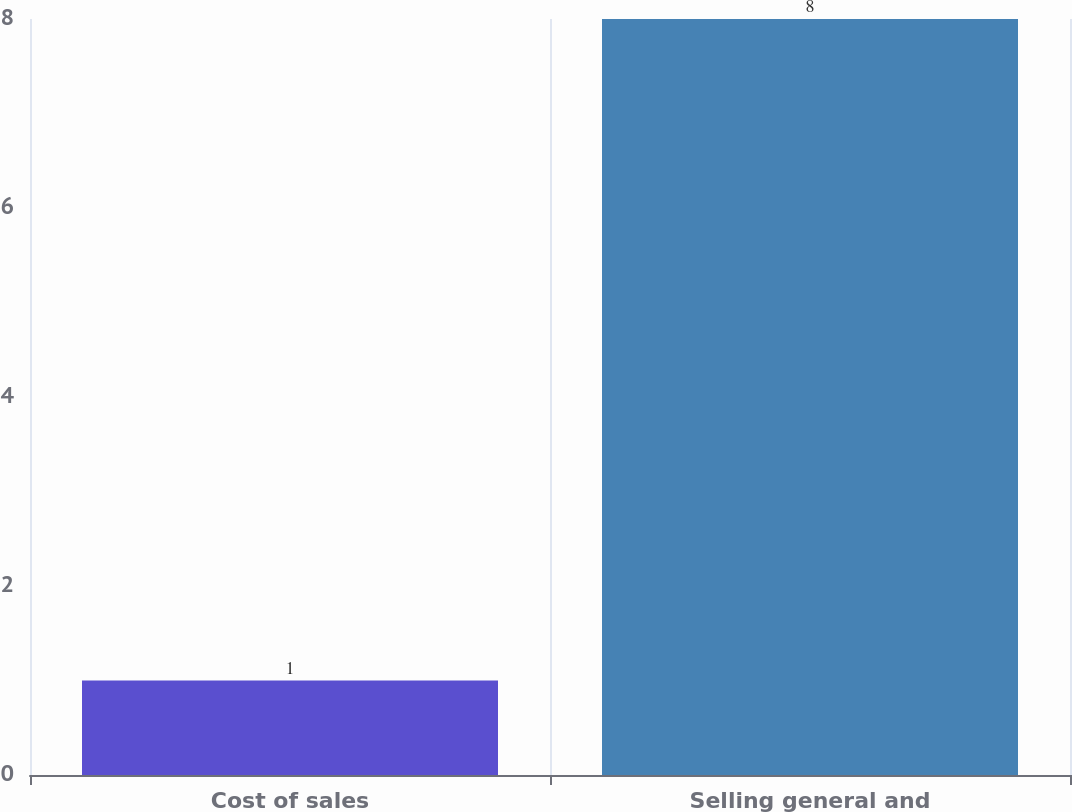Convert chart. <chart><loc_0><loc_0><loc_500><loc_500><bar_chart><fcel>Cost of sales<fcel>Selling general and<nl><fcel>1<fcel>8<nl></chart> 